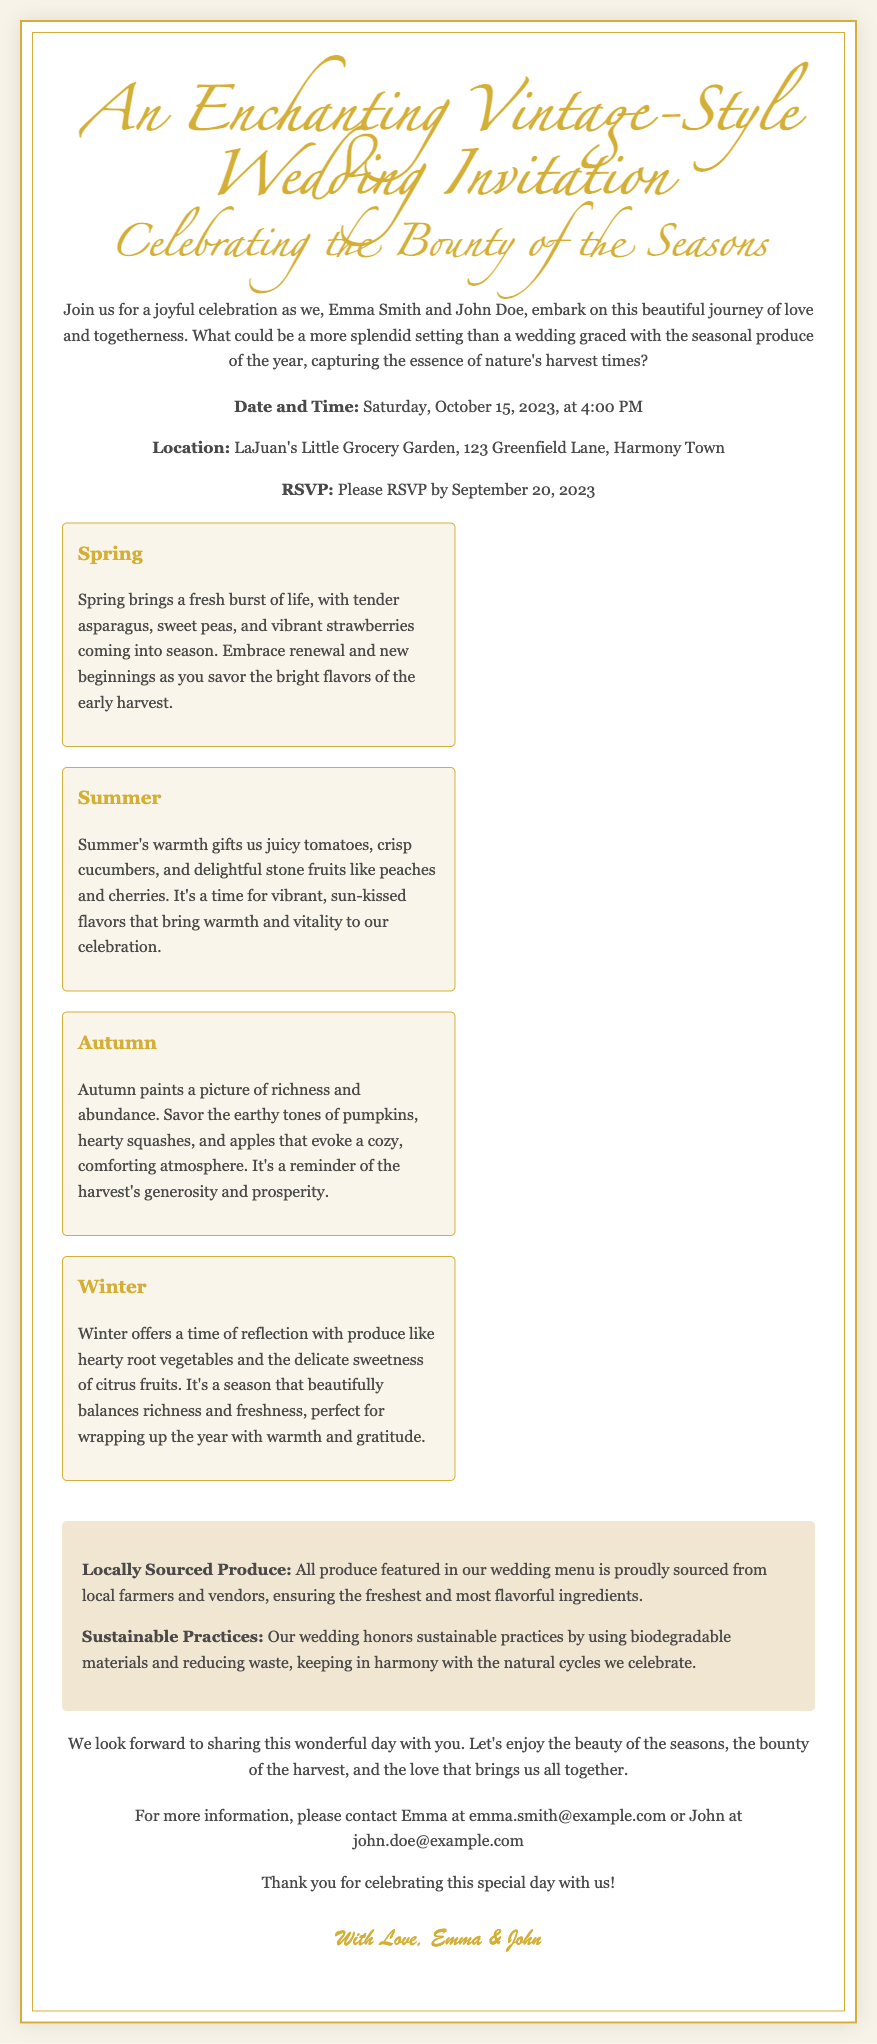What are the names of the couple? The names of the couple are mentioned in the introduction of the invitation.
Answer: Emma Smith and John Doe What is the date of the wedding? The document specifies the date and time of the wedding within the details section.
Answer: Saturday, October 15, 2023 Where is the wedding location? The location is listed in the details section, which provides the address for the event.
Answer: LaJuan's Little Grocery Garden, 123 Greenfield Lane, Harmony Town When is the RSVP deadline? The RSVP deadline is clearly stated in the details section of the invitation.
Answer: September 20, 2023 What seasonal produce is highlighted for Spring? Information about Spring's seasonal produce is found in the seasons section of the invitation.
Answer: Asparagus, sweet peas, strawberries What does Autumn represent in the invitation? The significance of Autumn is discussed in its corresponding section regarding the harvest and atmosphere.
Answer: Richness and abundance What is emphasized about the produce served? This focus is mentioned in the highlights section of the invitation, regarding sourcing practices.
Answer: Locally sourced What kind of practices does the wedding honor? The sustainable practices are outlined in the highlights section of the invitation.
Answer: Sustainable practices Who can be contacted for more information? Contact information is provided in the footer, indicating who to reach out to for further details.
Answer: Emma or John 